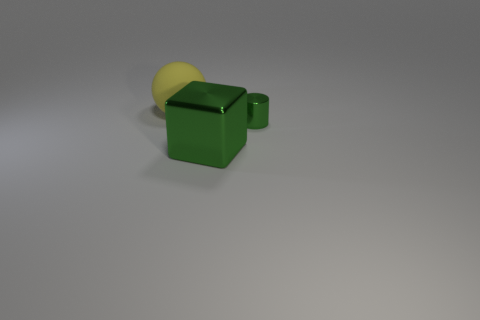How many other things are the same color as the large block?
Offer a very short reply. 1. How many big green metallic things are the same shape as the large rubber thing?
Make the answer very short. 0. Does the yellow thing have the same material as the green cube?
Make the answer very short. No. There is a big thing in front of the rubber object that is behind the green cube; what shape is it?
Make the answer very short. Cube. There is a green object that is behind the large block; what number of large rubber balls are to the right of it?
Ensure brevity in your answer.  0. There is a thing that is both behind the big block and in front of the yellow sphere; what is it made of?
Offer a terse response. Metal. There is a green metal object that is the same size as the matte object; what shape is it?
Offer a terse response. Cube. What color is the shiny object on the left side of the green object on the right side of the metal block that is in front of the tiny metallic object?
Provide a succinct answer. Green. How many things are either green metal objects behind the metallic block or big green metal cubes?
Ensure brevity in your answer.  2. What is the material of the other object that is the same size as the rubber object?
Your answer should be very brief. Metal. 